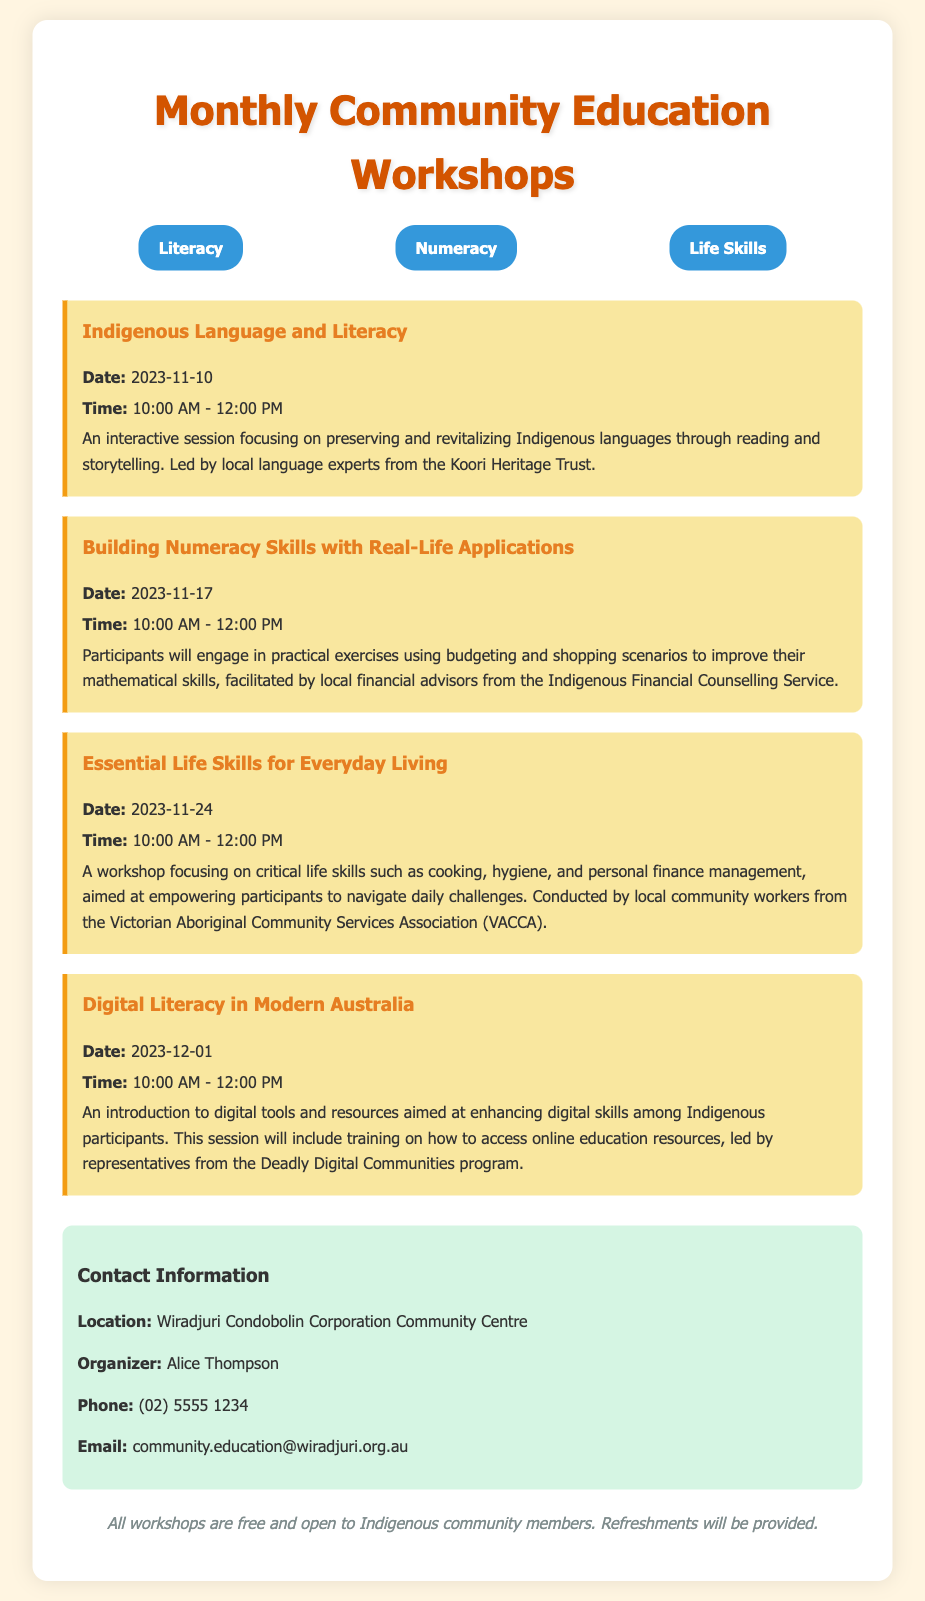What is the title of the document? The title of the document is presented at the top and indicates the subject of the agenda.
Answer: Monthly Community Education Workshops What is the date of the first workshop? The date of the first workshop is specified in the session details of the document.
Answer: 2023-11-10 Who is the organizer of the workshops? The organizer's name is listed under the contact information section.
Answer: Alice Thompson What skill does the session on November 17 focus on? The focus of this session is explicitly stated in the title of the session.
Answer: Building Numeracy Skills with Real-Life Applications Which organization is leading the Digital Literacy session? The name of the organization is mentioned in the description of the Digital Literacy session.
Answer: Deadly Digital Communities How long is each workshop scheduled to last? The duration is indicated in the time details for each session.
Answer: 2 hours What type of support is provided during the workshops? The document notes what will be provided to participants, indicating an additional benefit.
Answer: Refreshments What location hosts these workshops? The hosting location is specified in the contact information section of the document.
Answer: Wiradjuri Condobolin Corporation Community Centre 